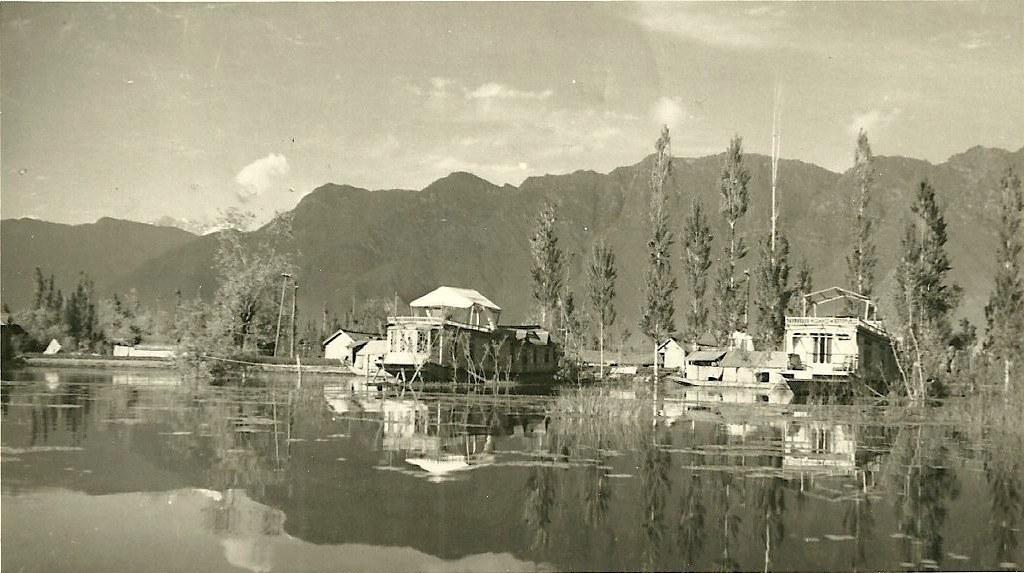In one or two sentences, can you explain what this image depicts? This is a black and white image. In this image I can see boats, houses, poles, trees and mountains in the center of the image. At the bottom of the image I can see the reflection of all of them in lake water. At the top of the image I can see the sky. 